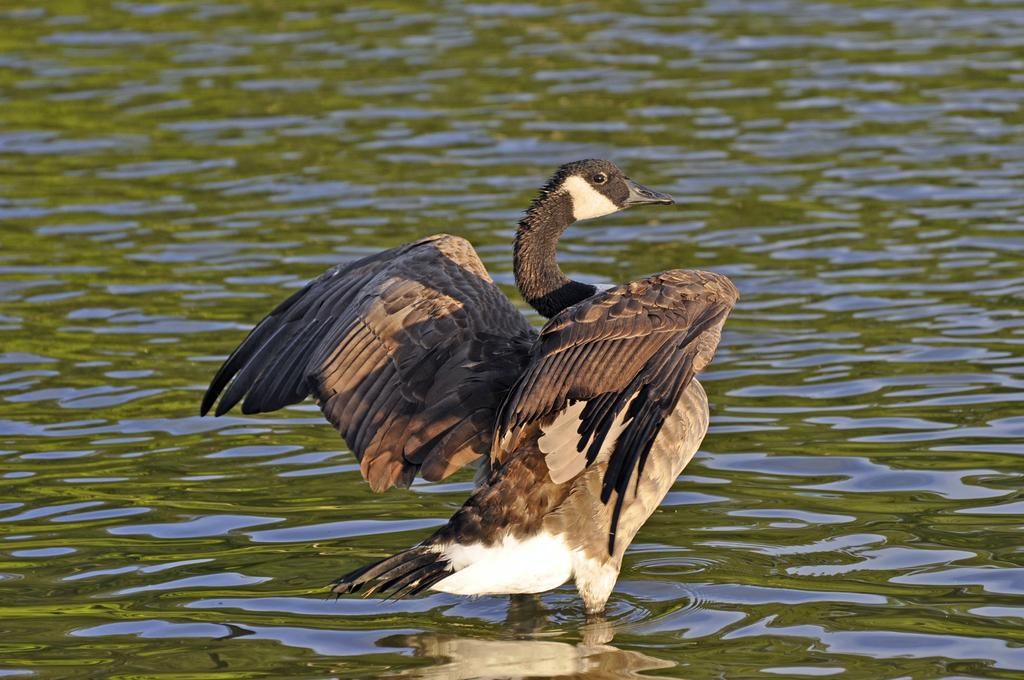What type of animal can be seen in the image? There is a bird in the image. Where is the bird located? The bird is in a large water body. What type of education does the bird have in the image? There is no information about the bird's education in the image. Where is the mailbox located in the image? There is no mailbox present in the image. 